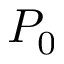Convert formula to latex. <formula><loc_0><loc_0><loc_500><loc_500>P _ { 0 }</formula> 